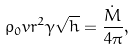<formula> <loc_0><loc_0><loc_500><loc_500>\rho _ { 0 } v r ^ { 2 } \gamma \sqrt { h } = \frac { \dot { M } } { 4 \pi } ,</formula> 